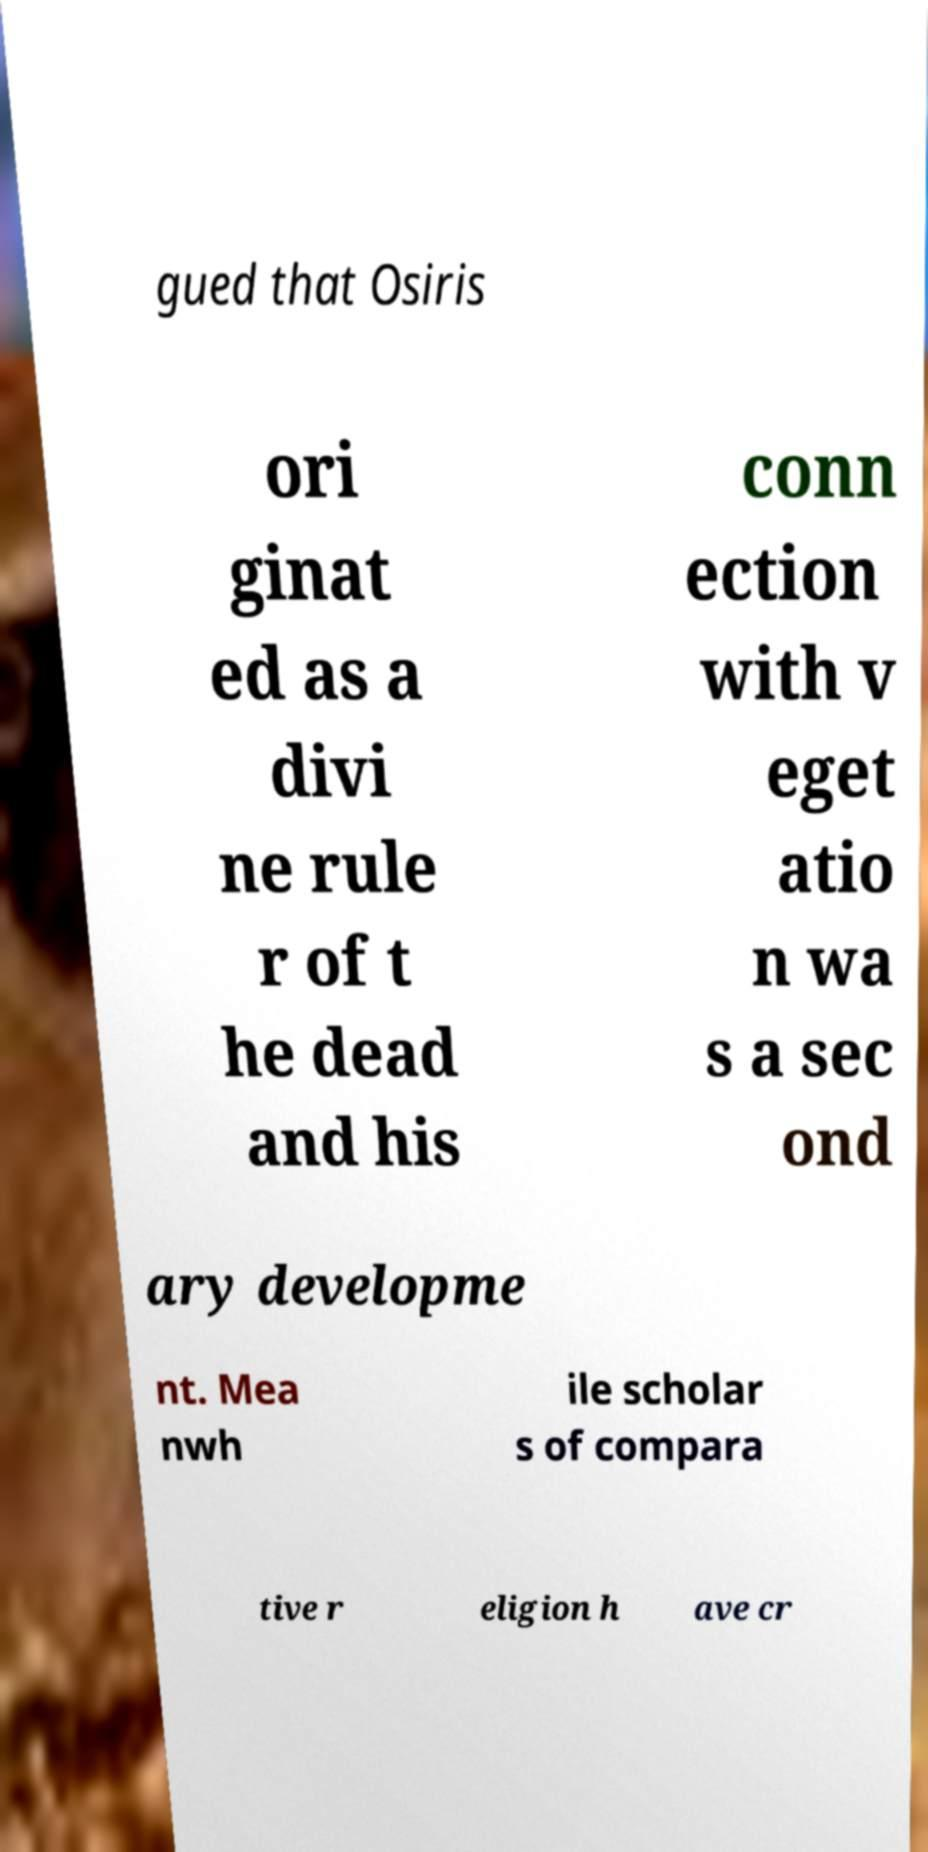There's text embedded in this image that I need extracted. Can you transcribe it verbatim? gued that Osiris ori ginat ed as a divi ne rule r of t he dead and his conn ection with v eget atio n wa s a sec ond ary developme nt. Mea nwh ile scholar s of compara tive r eligion h ave cr 